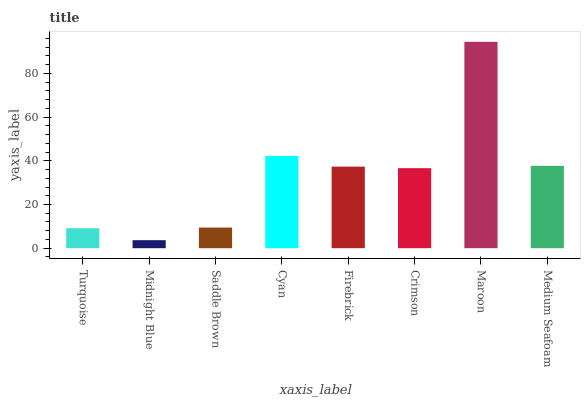Is Midnight Blue the minimum?
Answer yes or no. Yes. Is Maroon the maximum?
Answer yes or no. Yes. Is Saddle Brown the minimum?
Answer yes or no. No. Is Saddle Brown the maximum?
Answer yes or no. No. Is Saddle Brown greater than Midnight Blue?
Answer yes or no. Yes. Is Midnight Blue less than Saddle Brown?
Answer yes or no. Yes. Is Midnight Blue greater than Saddle Brown?
Answer yes or no. No. Is Saddle Brown less than Midnight Blue?
Answer yes or no. No. Is Firebrick the high median?
Answer yes or no. Yes. Is Crimson the low median?
Answer yes or no. Yes. Is Maroon the high median?
Answer yes or no. No. Is Saddle Brown the low median?
Answer yes or no. No. 